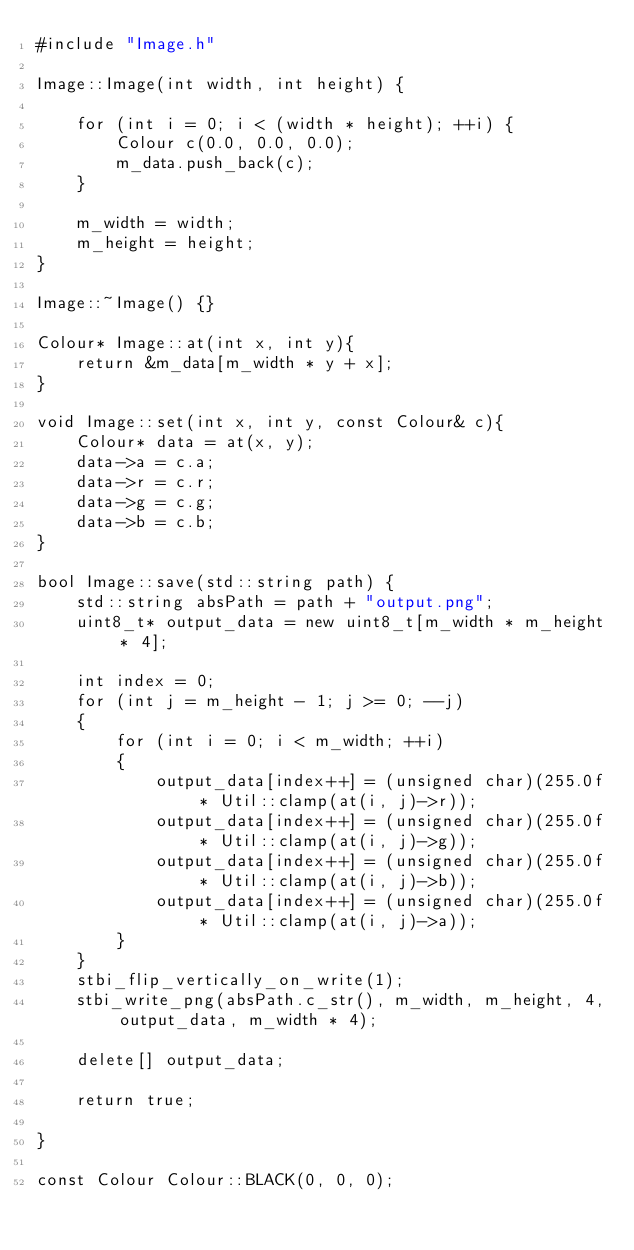<code> <loc_0><loc_0><loc_500><loc_500><_C++_>#include "Image.h"

Image::Image(int width, int height) {

	for (int i = 0; i < (width * height); ++i) {
		Colour c(0.0, 0.0, 0.0);
		m_data.push_back(c);
	}

	m_width = width;
	m_height = height;
}

Image::~Image() {}

Colour* Image::at(int x, int y){
	return &m_data[m_width * y + x];
}

void Image::set(int x, int y, const Colour& c){
	Colour* data = at(x, y);
	data->a = c.a;
	data->r = c.r;
	data->g = c.g;
	data->b = c.b;
}

bool Image::save(std::string path) {
	std::string absPath = path + "output.png";
	uint8_t* output_data = new uint8_t[m_width * m_height * 4];

	int index = 0;
	for (int j = m_height - 1; j >= 0; --j)
	{
		for (int i = 0; i < m_width; ++i)
		{
			output_data[index++] = (unsigned char)(255.0f * Util::clamp(at(i, j)->r));
			output_data[index++] = (unsigned char)(255.0f * Util::clamp(at(i, j)->g));
			output_data[index++] = (unsigned char)(255.0f * Util::clamp(at(i, j)->b));
			output_data[index++] = (unsigned char)(255.0f * Util::clamp(at(i, j)->a));
		}
	}
	stbi_flip_vertically_on_write(1);
	stbi_write_png(absPath.c_str(), m_width, m_height, 4, output_data, m_width * 4);

	delete[] output_data;

	return true;

}

const Colour Colour::BLACK(0, 0, 0);
</code> 